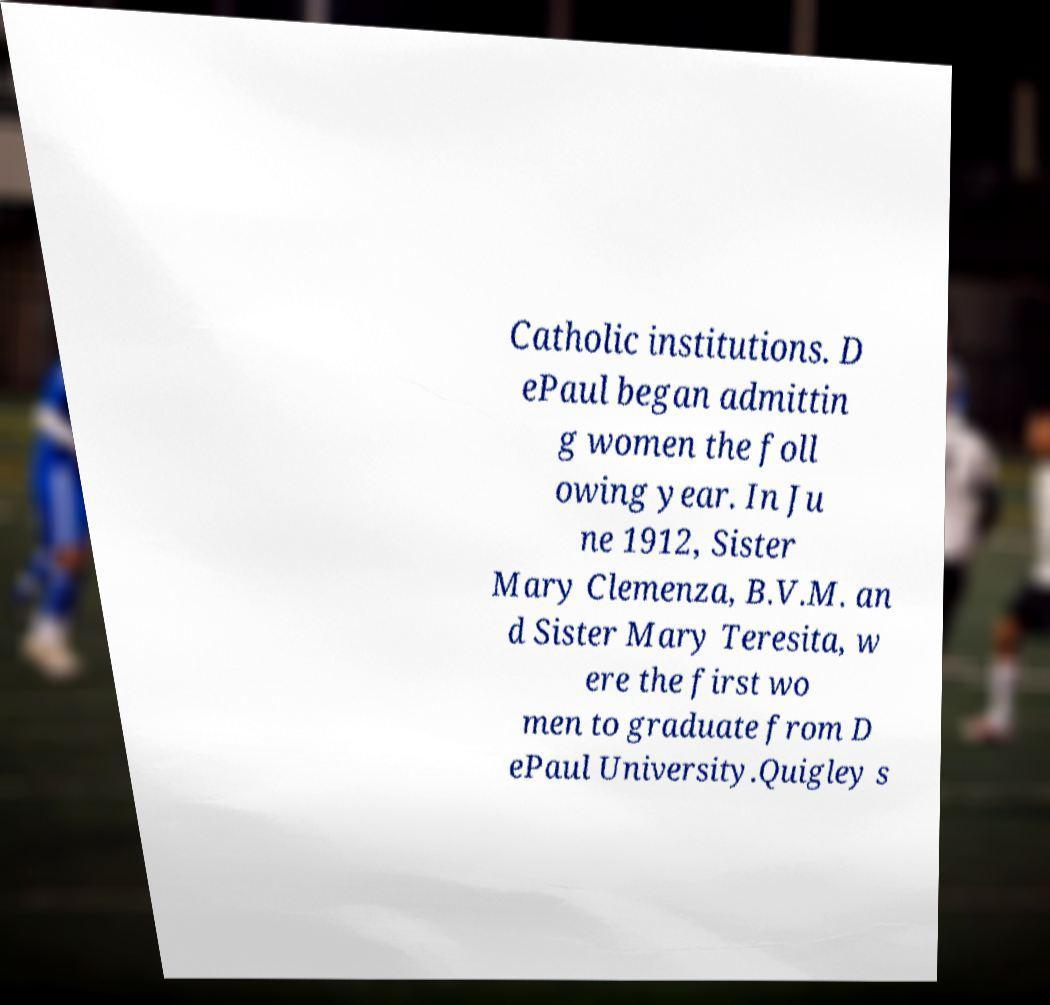Could you assist in decoding the text presented in this image and type it out clearly? Catholic institutions. D ePaul began admittin g women the foll owing year. In Ju ne 1912, Sister Mary Clemenza, B.V.M. an d Sister Mary Teresita, w ere the first wo men to graduate from D ePaul University.Quigley s 